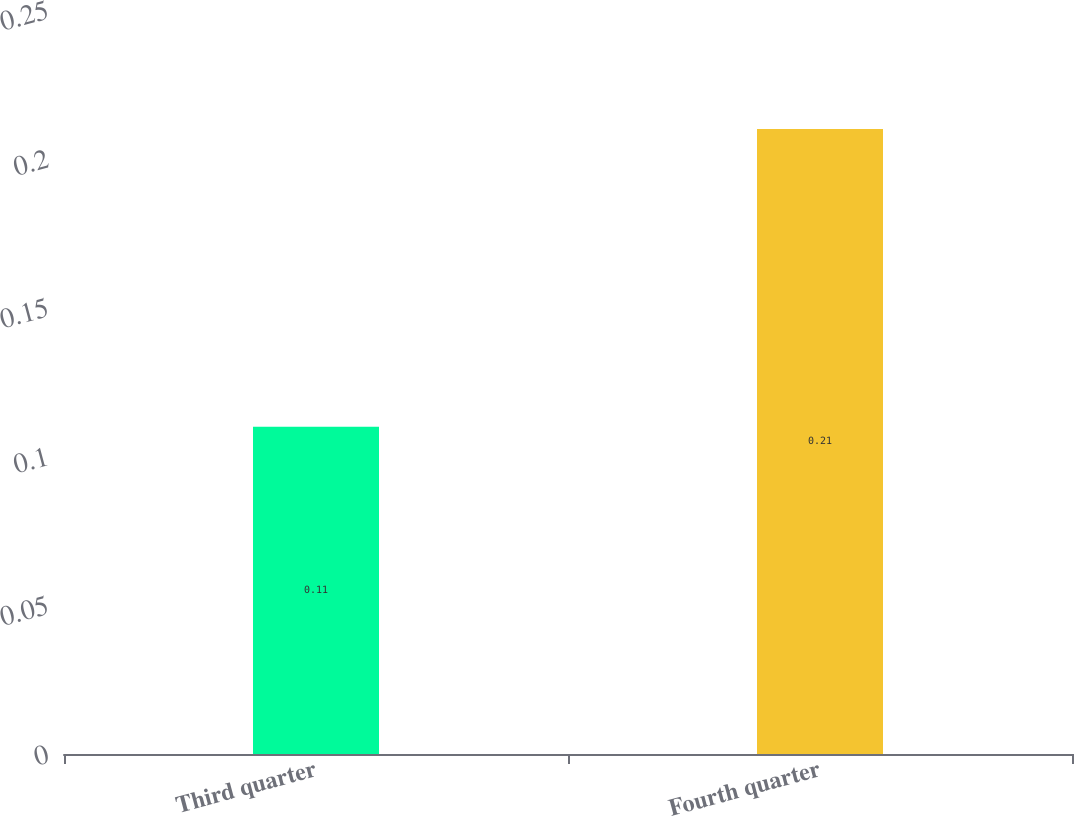Convert chart to OTSL. <chart><loc_0><loc_0><loc_500><loc_500><bar_chart><fcel>Third quarter<fcel>Fourth quarter<nl><fcel>0.11<fcel>0.21<nl></chart> 